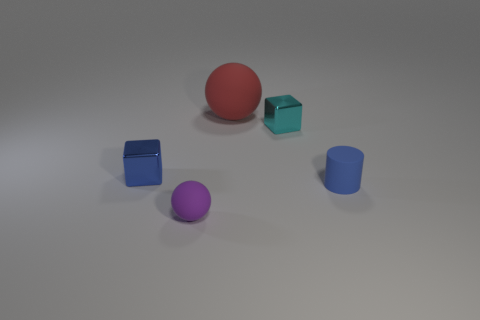Subtract all purple balls. How many balls are left? 1 Add 1 large red rubber spheres. How many objects exist? 6 Subtract all cyan cylinders. How many purple spheres are left? 1 Subtract 0 gray cylinders. How many objects are left? 5 Subtract all spheres. How many objects are left? 3 Subtract 2 blocks. How many blocks are left? 0 Subtract all cyan cylinders. Subtract all brown blocks. How many cylinders are left? 1 Subtract all big objects. Subtract all tiny blue rubber objects. How many objects are left? 3 Add 5 small cyan metallic blocks. How many small cyan metallic blocks are left? 6 Add 2 big metal objects. How many big metal objects exist? 2 